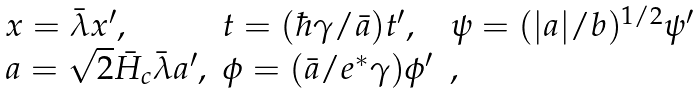<formula> <loc_0><loc_0><loc_500><loc_500>\begin{array} { l l l } { x } = \bar { \lambda } { x } ^ { \prime } , & t = ( \hbar { \gamma } / \bar { a } ) t ^ { \prime } , & \psi = ( | a | / b ) ^ { 1 / 2 } \psi ^ { \prime } \\ { a } = \sqrt { 2 } \bar { H } _ { c } \bar { \lambda } { a } ^ { \prime } , & \phi = ( \bar { a } / e ^ { * } \gamma ) \phi ^ { \prime } & , \end{array}</formula> 